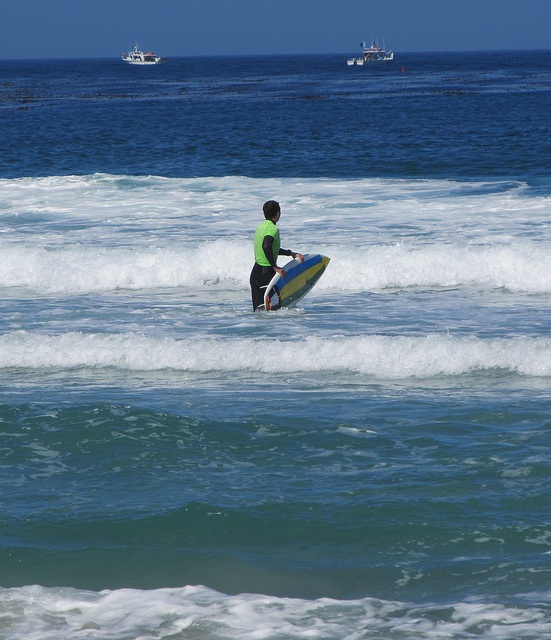Describe the objects in this image and their specific colors. I can see people in blue, black, and lightgreen tones, surfboard in blue, gray, darkblue, and olive tones, boat in blue, navy, gray, and darkblue tones, and boat in blue, gray, navy, and darkgray tones in this image. 